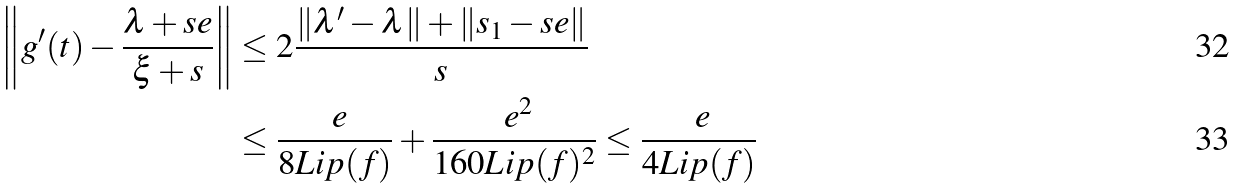<formula> <loc_0><loc_0><loc_500><loc_500>\left \| g ^ { \prime } ( t ) - \frac { \lambda + s e } { \xi + s } \right \| & \leq 2 \frac { \| \lambda ^ { \prime } - \lambda \| + \| s _ { 1 } - s e \| } { s } \\ & \leq \frac { \ e } { 8 L i p ( f ) } + \frac { \ e ^ { 2 } } { 1 6 0 L i p ( f ) ^ { 2 } } \leq \frac { \ e } { 4 L i p ( f ) }</formula> 